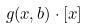Convert formula to latex. <formula><loc_0><loc_0><loc_500><loc_500>g ( x , b ) \cdot [ x ]</formula> 